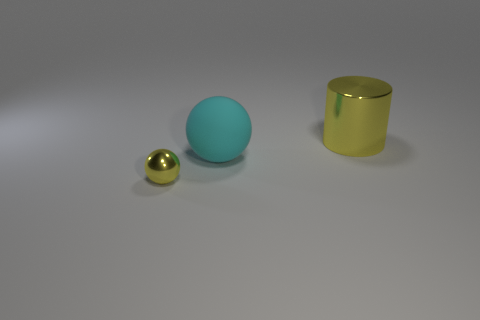The yellow thing in front of the metal thing behind the yellow thing in front of the big yellow thing is made of what material?
Ensure brevity in your answer.  Metal. Does the thing left of the large ball have the same material as the yellow thing right of the tiny metallic object?
Ensure brevity in your answer.  Yes. What is the size of the object that is in front of the big yellow metal cylinder and behind the tiny shiny ball?
Provide a short and direct response. Large. There is a thing that is the same size as the yellow cylinder; what is its material?
Provide a short and direct response. Rubber. How many shiny things are in front of the metallic thing that is in front of the yellow metal thing behind the small yellow shiny ball?
Offer a very short reply. 0. Do the metal thing left of the big cyan sphere and the big object in front of the large yellow metal cylinder have the same color?
Provide a succinct answer. No. What color is the object that is right of the metallic sphere and on the left side of the large shiny object?
Offer a very short reply. Cyan. How many other objects are the same size as the matte thing?
Provide a succinct answer. 1. There is a yellow thing that is to the right of the yellow object on the left side of the large yellow thing; what is its shape?
Make the answer very short. Cylinder. What is the shape of the metallic object that is on the left side of the metallic thing that is behind the big cyan rubber object behind the yellow metallic sphere?
Ensure brevity in your answer.  Sphere. 